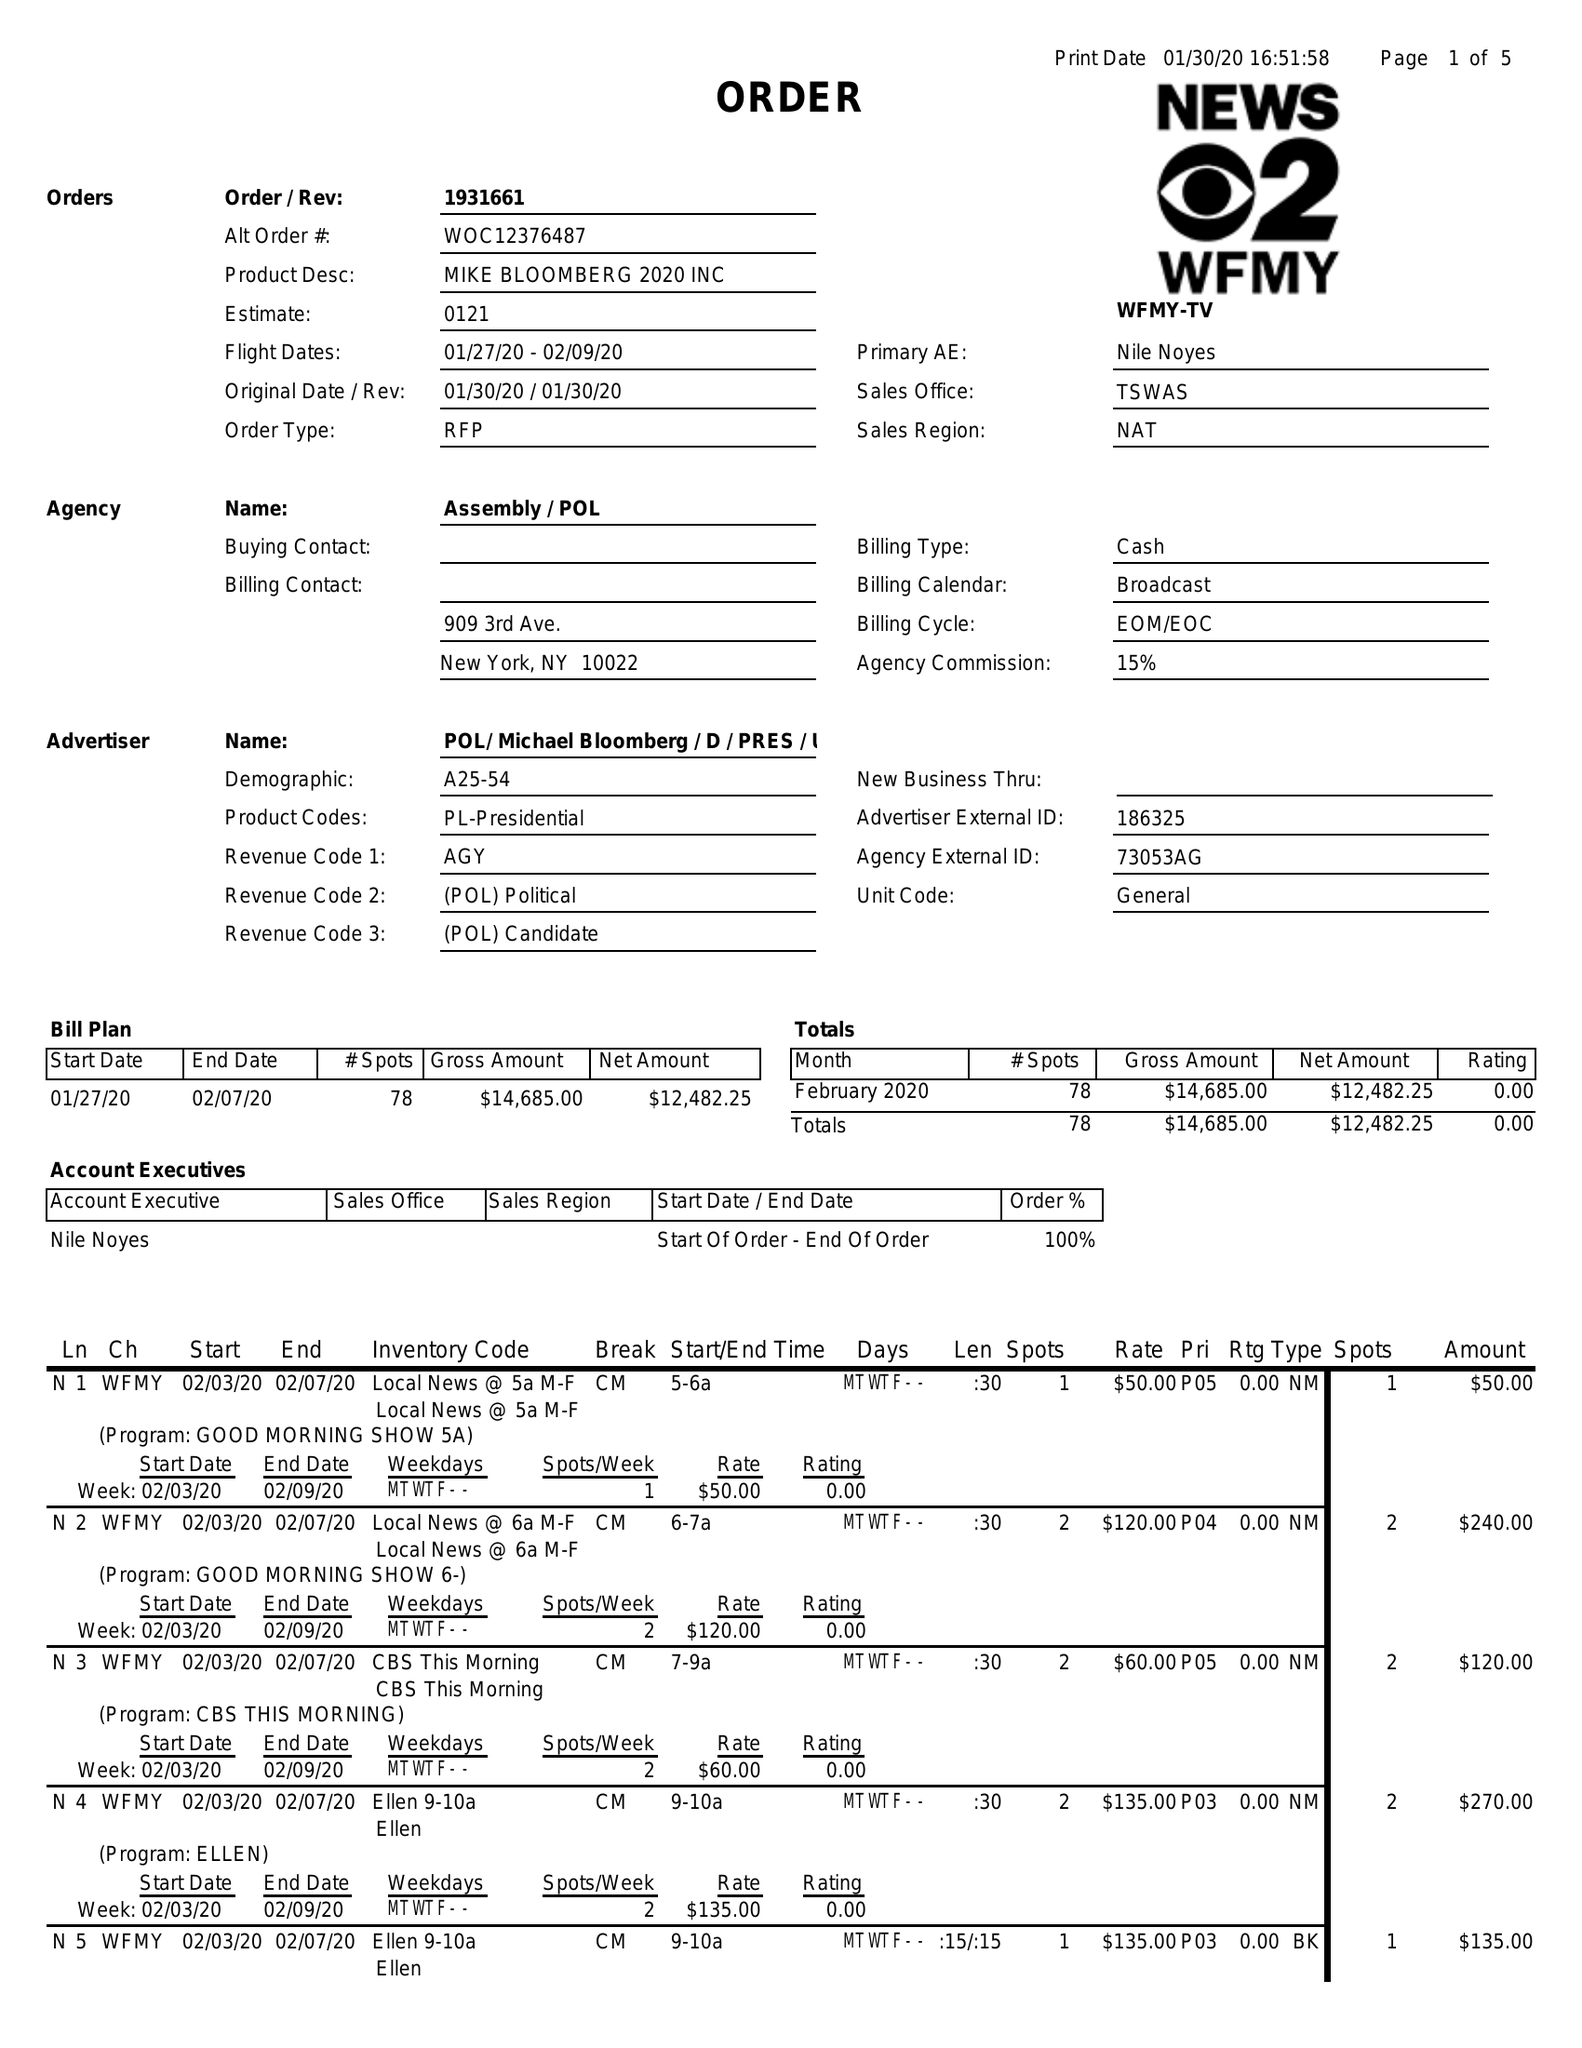What is the value for the flight_from?
Answer the question using a single word or phrase. 01/27/20 